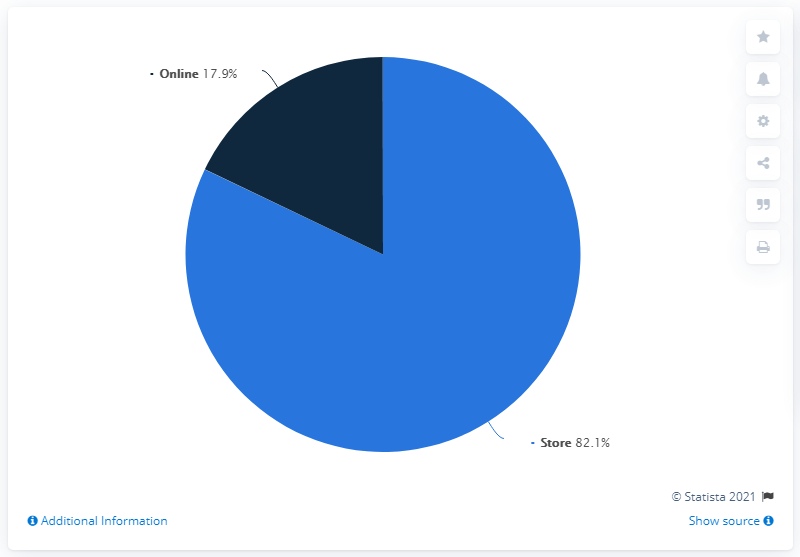Outline some significant characteristics in this image. The sales channel that is most dominant on the chart is the store. The stores are higher by 64.2% than the online version. 